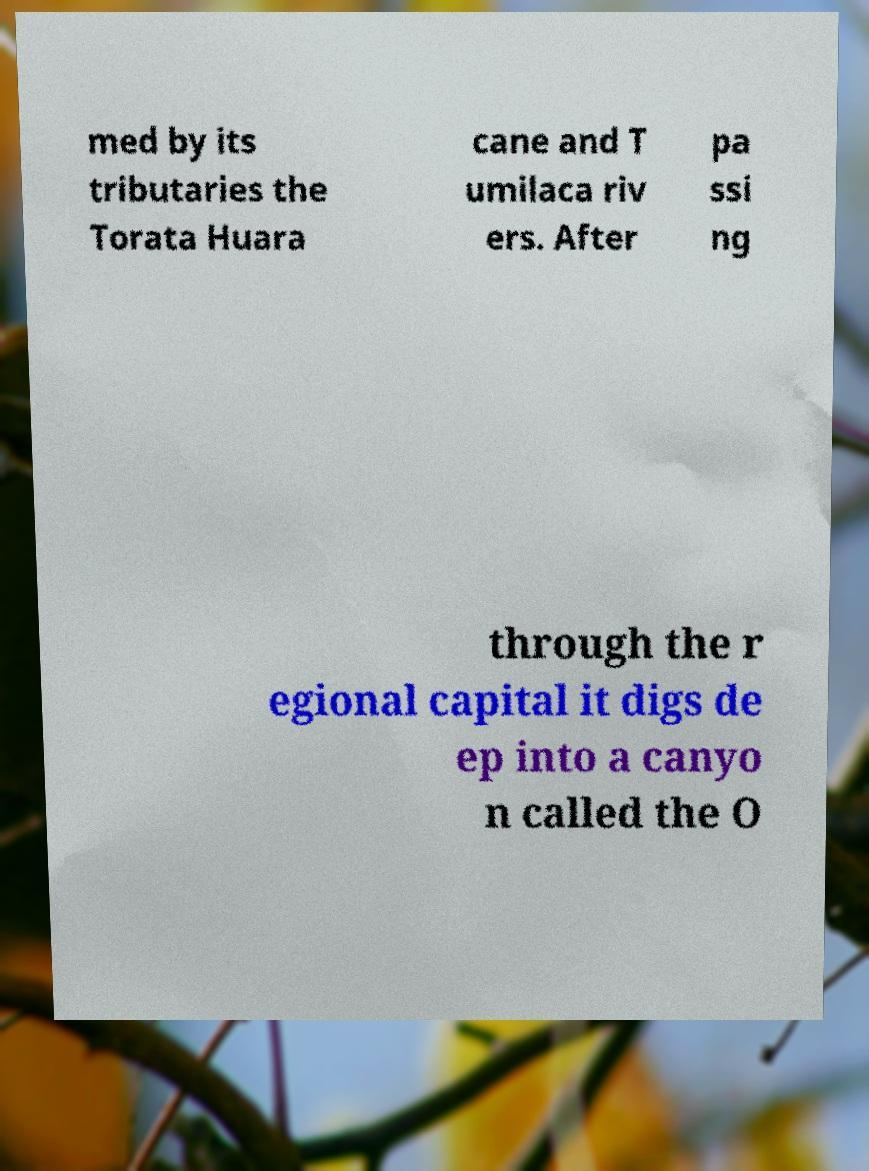There's text embedded in this image that I need extracted. Can you transcribe it verbatim? med by its tributaries the Torata Huara cane and T umilaca riv ers. After pa ssi ng through the r egional capital it digs de ep into a canyo n called the O 